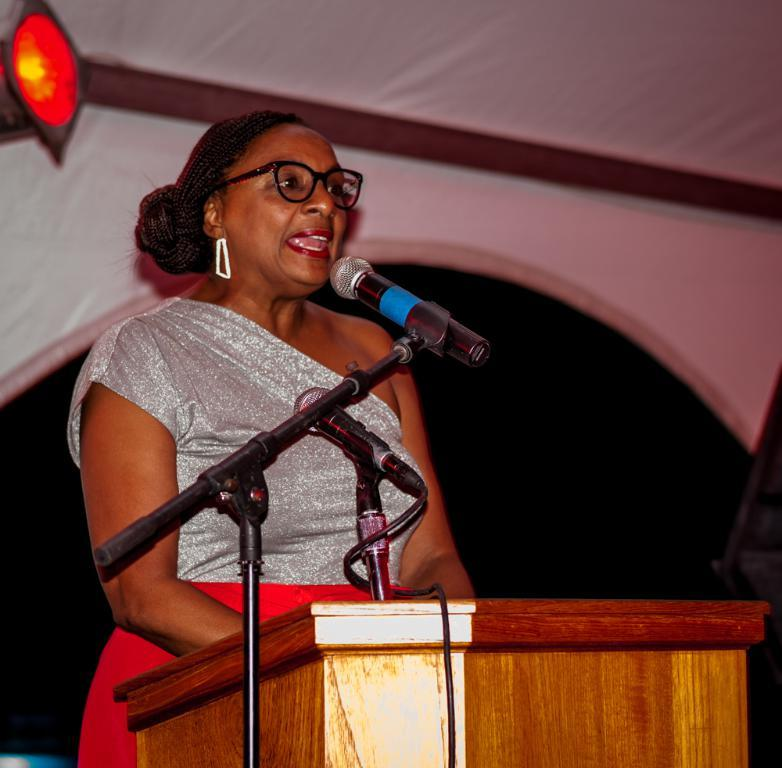Who is the main subject in the image? There is a woman in the image. What is the woman doing in the image? The woman is standing at a podium. What is the woman using to amplify her voice in the image? There is a microphone in front of the woman. What can be seen in the background of the image? There are electric lights and walls visible in the background of the image. What type of crow is resting on the woman's shoulder in the image? There is no crow present in the image; the woman is standing at a podium with a microphone in front of her. What color is the chalk the woman is using to write on the wall in the image? There is no chalk or writing on the wall in the image; the woman is standing at a podium with a microphone in front of her. 